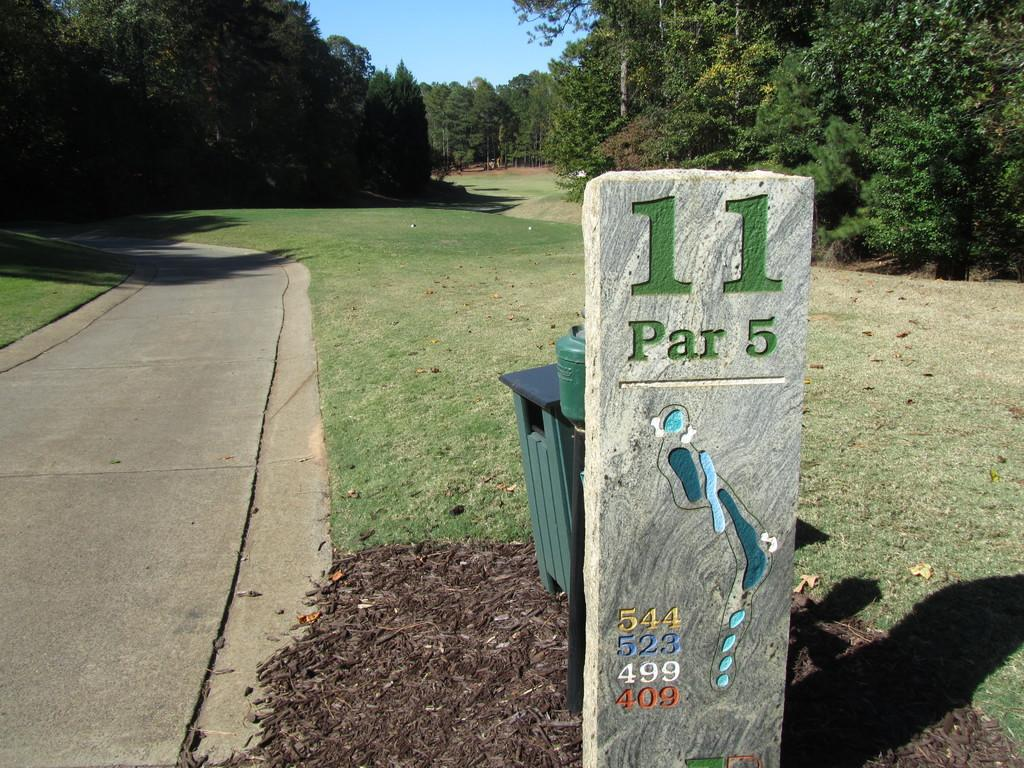<image>
Summarize the visual content of the image. 11 is a Par 5 marks this golf hole according to the sign. 